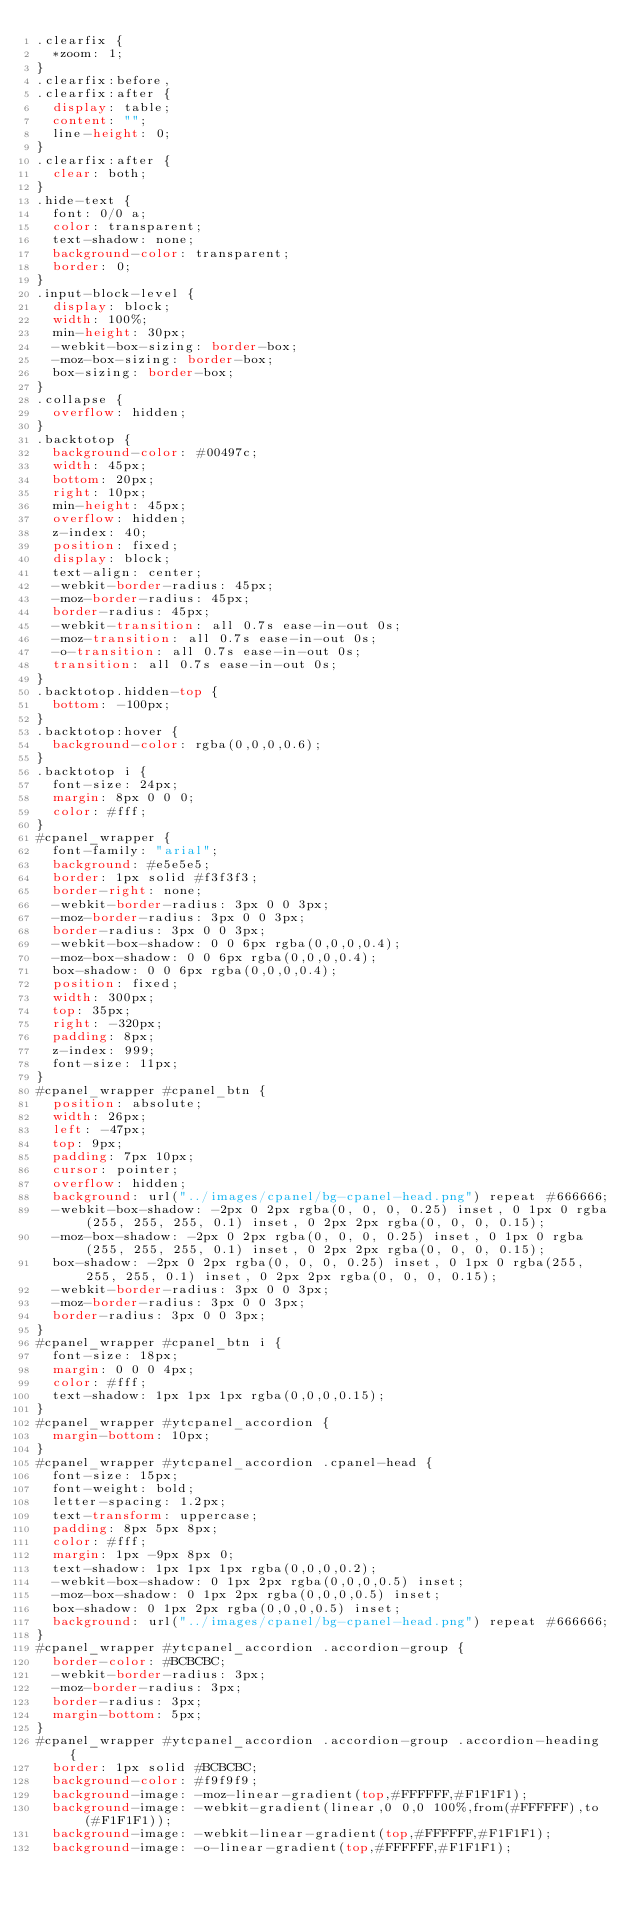Convert code to text. <code><loc_0><loc_0><loc_500><loc_500><_CSS_>.clearfix {
  *zoom: 1;
}
.clearfix:before,
.clearfix:after {
  display: table;
  content: "";
  line-height: 0;
}
.clearfix:after {
  clear: both;
}
.hide-text {
  font: 0/0 a;
  color: transparent;
  text-shadow: none;
  background-color: transparent;
  border: 0;
}
.input-block-level {
  display: block;
  width: 100%;
  min-height: 30px;
  -webkit-box-sizing: border-box;
  -moz-box-sizing: border-box;
  box-sizing: border-box;
}
.collapse {
  overflow: hidden;
}
.backtotop {
  background-color: #00497c;
  width: 45px;
  bottom: 20px;
  right: 10px;
  min-height: 45px;
  overflow: hidden;
  z-index: 40;
  position: fixed;
  display: block;
  text-align: center;
  -webkit-border-radius: 45px;
  -moz-border-radius: 45px;
  border-radius: 45px;
  -webkit-transition: all 0.7s ease-in-out 0s;
  -moz-transition: all 0.7s ease-in-out 0s;
  -o-transition: all 0.7s ease-in-out 0s;
  transition: all 0.7s ease-in-out 0s;
}
.backtotop.hidden-top {
  bottom: -100px;
}
.backtotop:hover {
  background-color: rgba(0,0,0,0.6);
}
.backtotop i {
  font-size: 24px;
  margin: 8px 0 0 0;
  color: #fff;
}
#cpanel_wrapper {
  font-family: "arial";
  background: #e5e5e5;
  border: 1px solid #f3f3f3;
  border-right: none;
  -webkit-border-radius: 3px 0 0 3px;
  -moz-border-radius: 3px 0 0 3px;
  border-radius: 3px 0 0 3px;
  -webkit-box-shadow: 0 0 6px rgba(0,0,0,0.4);
  -moz-box-shadow: 0 0 6px rgba(0,0,0,0.4);
  box-shadow: 0 0 6px rgba(0,0,0,0.4);
  position: fixed;
  width: 300px;
  top: 35px;
  right: -320px;
  padding: 8px;
  z-index: 999;
  font-size: 11px;
}
#cpanel_wrapper #cpanel_btn {
  position: absolute;
  width: 26px;
  left: -47px;
  top: 9px;
  padding: 7px 10px;
  cursor: pointer;
  overflow: hidden;
  background: url("../images/cpanel/bg-cpanel-head.png") repeat #666666;
  -webkit-box-shadow: -2px 0 2px rgba(0, 0, 0, 0.25) inset, 0 1px 0 rgba(255, 255, 255, 0.1) inset, 0 2px 2px rgba(0, 0, 0, 0.15);
  -moz-box-shadow: -2px 0 2px rgba(0, 0, 0, 0.25) inset, 0 1px 0 rgba(255, 255, 255, 0.1) inset, 0 2px 2px rgba(0, 0, 0, 0.15);
  box-shadow: -2px 0 2px rgba(0, 0, 0, 0.25) inset, 0 1px 0 rgba(255, 255, 255, 0.1) inset, 0 2px 2px rgba(0, 0, 0, 0.15);
  -webkit-border-radius: 3px 0 0 3px;
  -moz-border-radius: 3px 0 0 3px;
  border-radius: 3px 0 0 3px;
}
#cpanel_wrapper #cpanel_btn i {
  font-size: 18px;
  margin: 0 0 0 4px;
  color: #fff;
  text-shadow: 1px 1px 1px rgba(0,0,0,0.15);
}
#cpanel_wrapper #ytcpanel_accordion {
  margin-bottom: 10px;
}
#cpanel_wrapper #ytcpanel_accordion .cpanel-head {
  font-size: 15px;
  font-weight: bold;
  letter-spacing: 1.2px;
  text-transform: uppercase;
  padding: 8px 5px 8px;
  color: #fff;
  margin: 1px -9px 8px 0;
  text-shadow: 1px 1px 1px rgba(0,0,0,0.2);
  -webkit-box-shadow: 0 1px 2px rgba(0,0,0,0.5) inset;
  -moz-box-shadow: 0 1px 2px rgba(0,0,0,0.5) inset;
  box-shadow: 0 1px 2px rgba(0,0,0,0.5) inset;
  background: url("../images/cpanel/bg-cpanel-head.png") repeat #666666;
}
#cpanel_wrapper #ytcpanel_accordion .accordion-group {
  border-color: #BCBCBC;
  -webkit-border-radius: 3px;
  -moz-border-radius: 3px;
  border-radius: 3px;
  margin-bottom: 5px;
}
#cpanel_wrapper #ytcpanel_accordion .accordion-group .accordion-heading {
  border: 1px solid #BCBCBC;
  background-color: #f9f9f9;
  background-image: -moz-linear-gradient(top,#FFFFFF,#F1F1F1);
  background-image: -webkit-gradient(linear,0 0,0 100%,from(#FFFFFF),to(#F1F1F1));
  background-image: -webkit-linear-gradient(top,#FFFFFF,#F1F1F1);
  background-image: -o-linear-gradient(top,#FFFFFF,#F1F1F1);</code> 